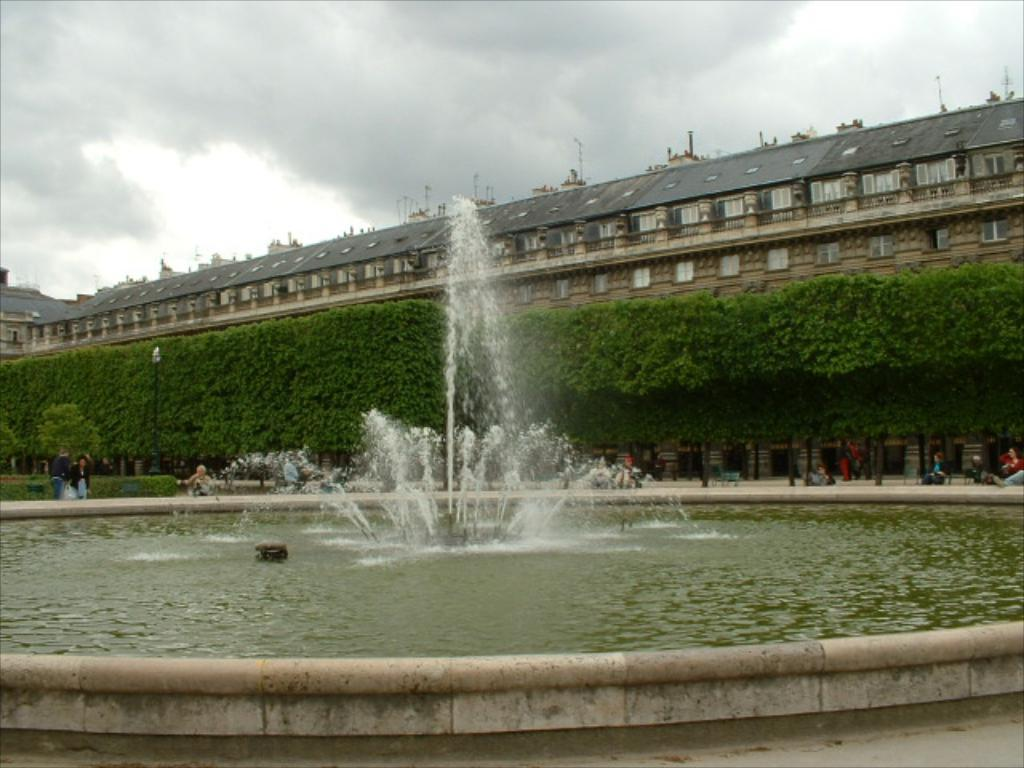What is the main feature in the image? There is a water fountain in the image. Can you describe the people in the image? There is a group of people in the image. What type of seating is available in the image? There are benches in the image. What type of vegetation is present in the image? There are trees in the image. What type of structure is visible in the image? There is a building in the image. What can be seen in the background of the image? The sky is visible in the background of the image. What type of cushion is being used by the people in the image? There is no cushion present in the image; the people are standing or sitting on the benches. What route are the people taking in the image? There is no indication of a specific route in the image; the people are gathered around the water fountain. 